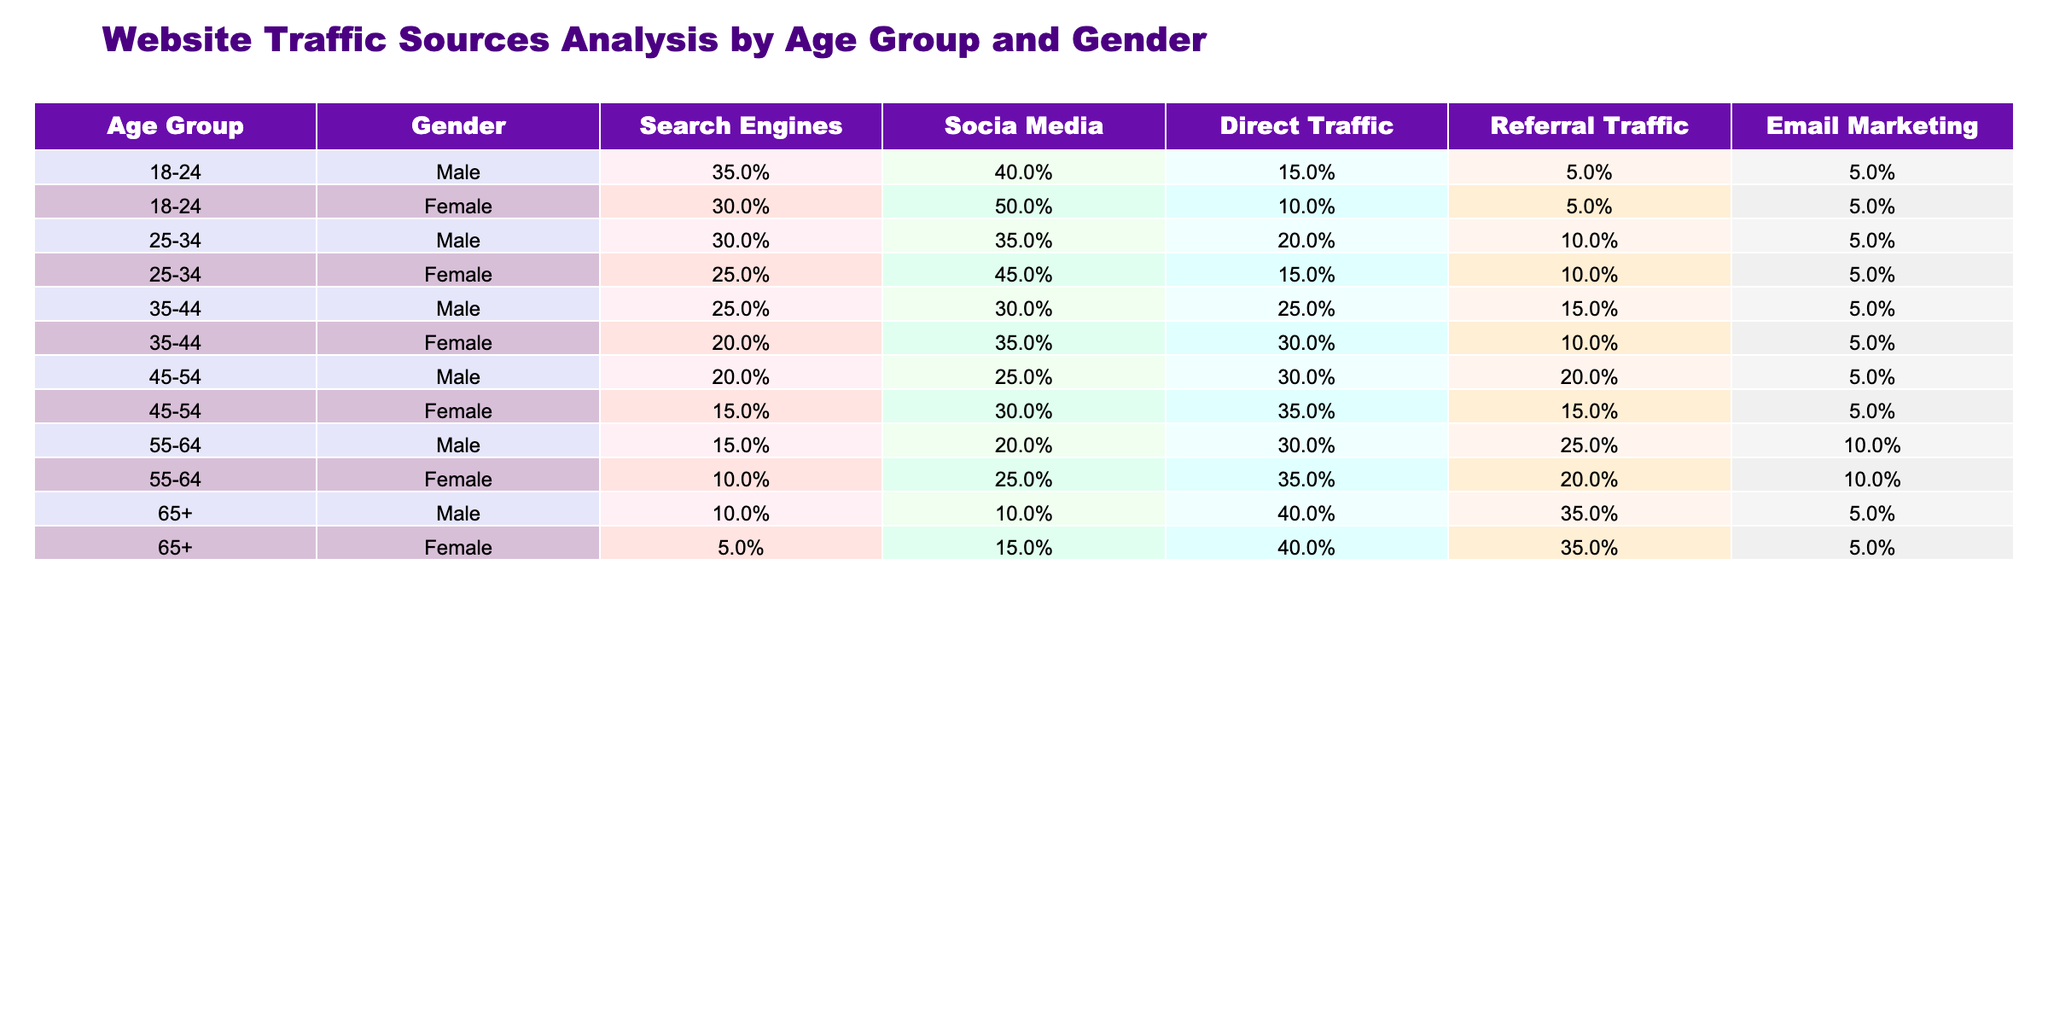What is the percentage of website traffic from social media for females aged 35-44? The table shows that females aged 35-44 receive 35% of their website traffic from social media.
Answer: 35% What is the total percentage of website traffic from email marketing for males across all age groups? To find the total percentage, we sum the email marketing percentages for all male age groups: 5% + 5% + 5% + 5% + 5% + 5% = 30%.
Answer: 30% Is the percentage of direct traffic for females aged 45-54 higher than that for females aged 25-34? Females aged 45-54 have 35% direct traffic while females aged 25-34 have 15%, thus 35% is higher than 15%.
Answer: Yes What is the average percentage of traffic from search engines for all age groups? For the average, we calculate the sum of the search engine percentages: (35 + 30 + 30 + 25 + 25 + 20 + 20 + 15 + 15 + 10 + 10 + 5) =  10 and 55%/12 = 18.33%.
Answer: 18.33% Which age group has the highest percentage of referral traffic for males? The 55-64 age group has 25% referral traffic, which is the highest among male age groups when compared with 15%, 10%, 20%, and so on.
Answer: 55-64 What is the lowest percentage of website traffic from social media for any gender and age group? For males aged 65+, the social media traffic is 10%, which is lower than any other age and gender combination in the table.
Answer: 10% What age group has the highest overall percentage of traffic from search engines? Males aged 18-24 have the highest percentage at 35%, which is adjacent to their female counterparts who have 30%.
Answer: 18-24 Is the total percentage of direct traffic higher for females in the 25-34 age group compared to the 45-54 age group? Females aged 25-34 have 15% direct traffic while females aged 45-54 have 35%, so 15% is lower than 35%.
Answer: No 